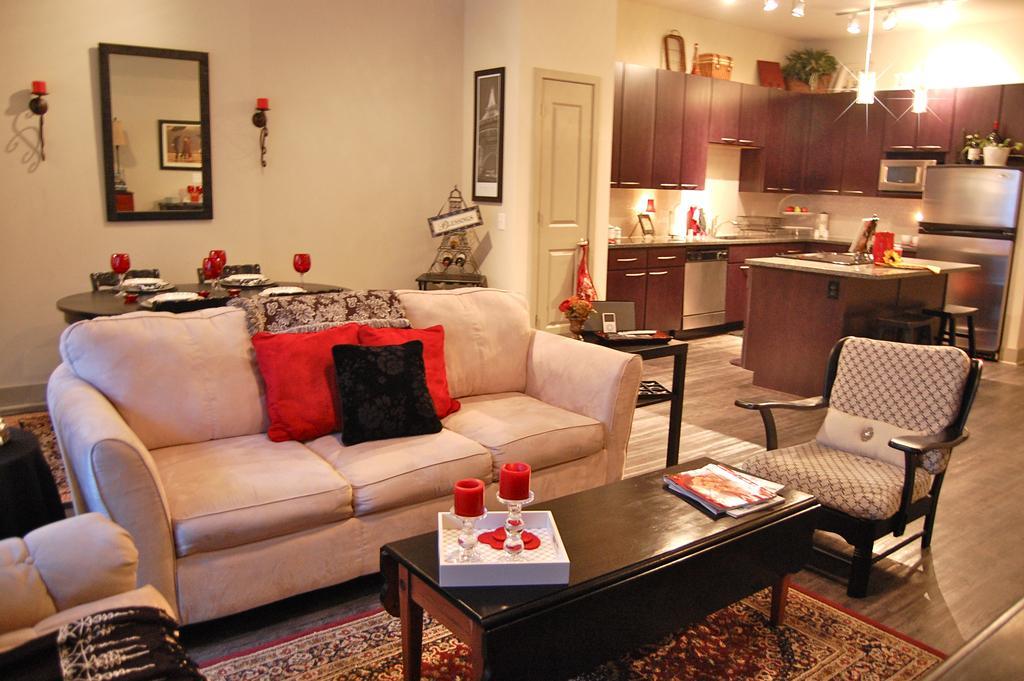Describe this image in one or two sentences. The photo is taken inside a room. There is a sofa in front of it there is a table. On the table there are candles ,books. On the floor there is a carpet. On the wall there is a mirror. In front of it there is a dining table. In the right there is a kitchen. 